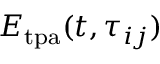<formula> <loc_0><loc_0><loc_500><loc_500>E _ { t p a } ( t , \tau _ { i j } )</formula> 